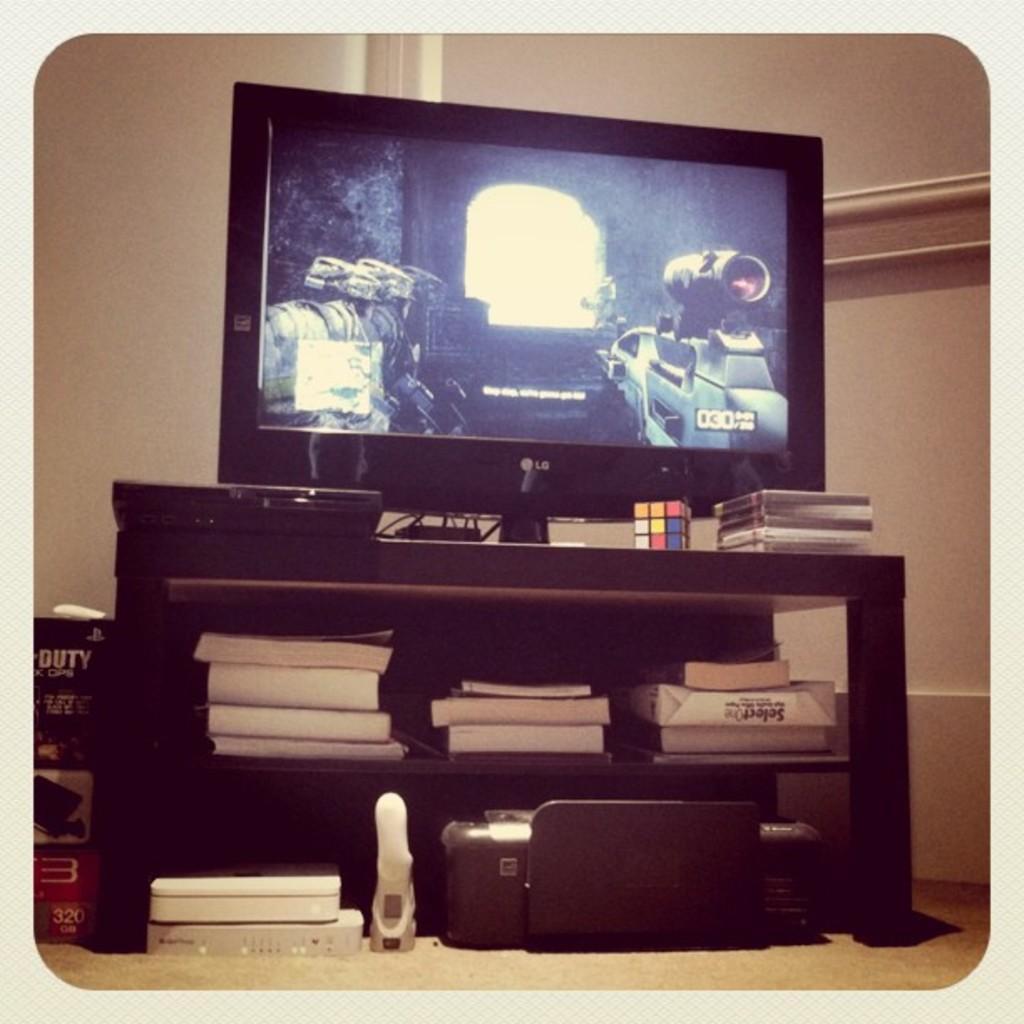Describe this image in one or two sentences. In this picture I can see a television on the table and I can see few books in the shelf and I can see a printer on the floor and a carton box on the left side and I can see a rubik's cube on the table and I can see plain background in the back. 